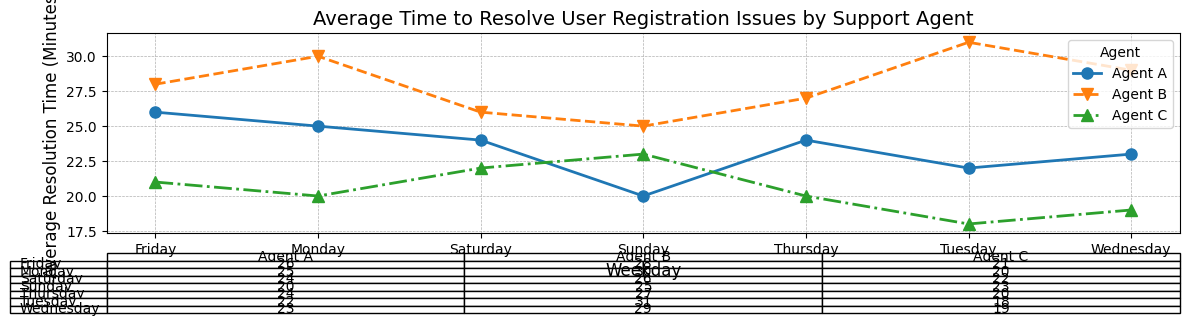Which support agent resolves issues the fastest on Mondays? Look at the plot data for Monday and find the agent with the lowest average resolution time. Agent C has the lowest average resolution time of 20 minutes.
Answer: Agent C On which day does Agent B have the highest average resolution time? Inspect the plot and table for Agent B's average resolution times across the weekdays and find the highest value. It is 31 minutes on Tuesday.
Answer: Tuesday What is the average resolution time for Agent A from Monday to Wednesday? Add the average times for Agent A from Monday to Wednesday and divide by the number of days: (25 + 22 + 23) / 3 = 70 / 3 = 23.33 minutes.
Answer: 23.33 minutes Who has the most consistent resolution times across all weekdays? Consistency implies the least variation in resolution times. Agent A's times range from 20 to 26 minutes, Agent B's from 25 to 31 minutes, and Agent C's from 18 to 23 minutes. Agent C is the most consistent.
Answer: Agent C Which agent has the shortest average resolution time overall? Observe the plot and table for each agent's performance across all days. Sum their times and divide by the number of days (7): Agent A: (25 + 22 + 23 + 24 + 26 + 24 + 20) / 7 = 23.57 minutes; Agent B: (30 + 31 + 29 + 27 + 28 + 26 + 25) / 7 = 28 minutes; Agent C: (20 + 18 + 19 + 20 + 21 + 22 + 23) / 7 = 20.43 minutes. Agent C has the shortest average time.
Answer: Agent C What is the difference in average resolution time between Agent A and Agent C on Thursday? Find the resolution times for Agent A and Agent C on Thursday and subtract: 24 - 20 = 4 minutes.
Answer: 4 minutes Is Agent B ever the fastest resolver on any given day? Compare Agent B's resolution times with the other agents for each day. Agent B's times are never the lowest on any day.
Answer: No Which day has the smallest difference in average resolution times between the fastest and slowest agents? Calculate the differences for each day. The smallest difference is on Sunday where times for agents are 20, 23, and 25 minutes. The difference is 25 - 20 = 5 minutes.
Answer: Sunday Who improves their average resolution time the most from Monday to Sunday? Subtract the average time on Sunday from the time on Monday for each agent: 
- Agent A: 25 - 20 = 5 minutes 
- Agent B: 30 - 25 = 5 minutes 
- Agent C: 20 - 23 = -3 minutes. 
Agents A and B improve by 5 minutes each.
Answer: Agents A and B 